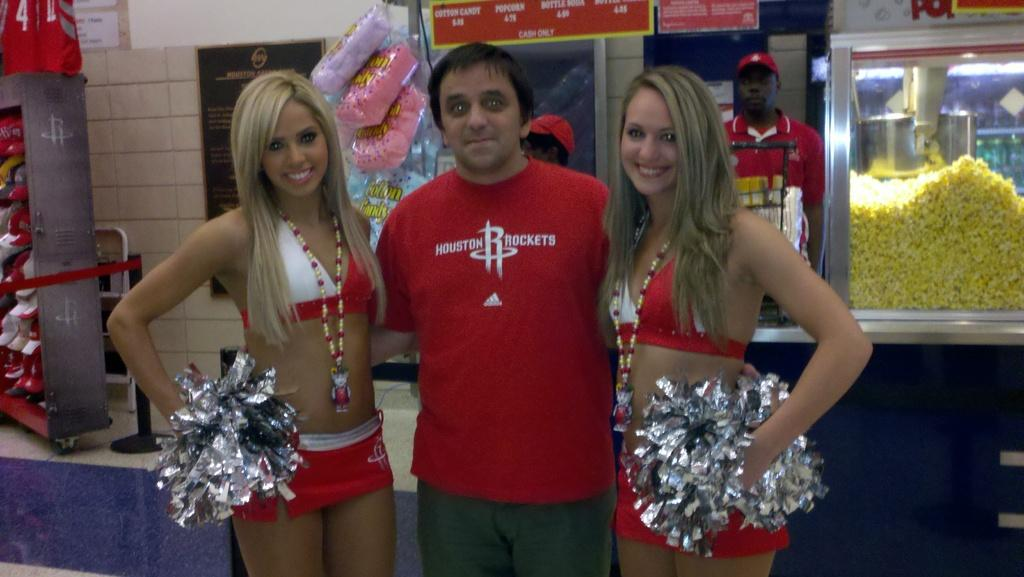<image>
Create a compact narrative representing the image presented. A man in a red Houston Rockets shirt poses with two cheer leaders. 